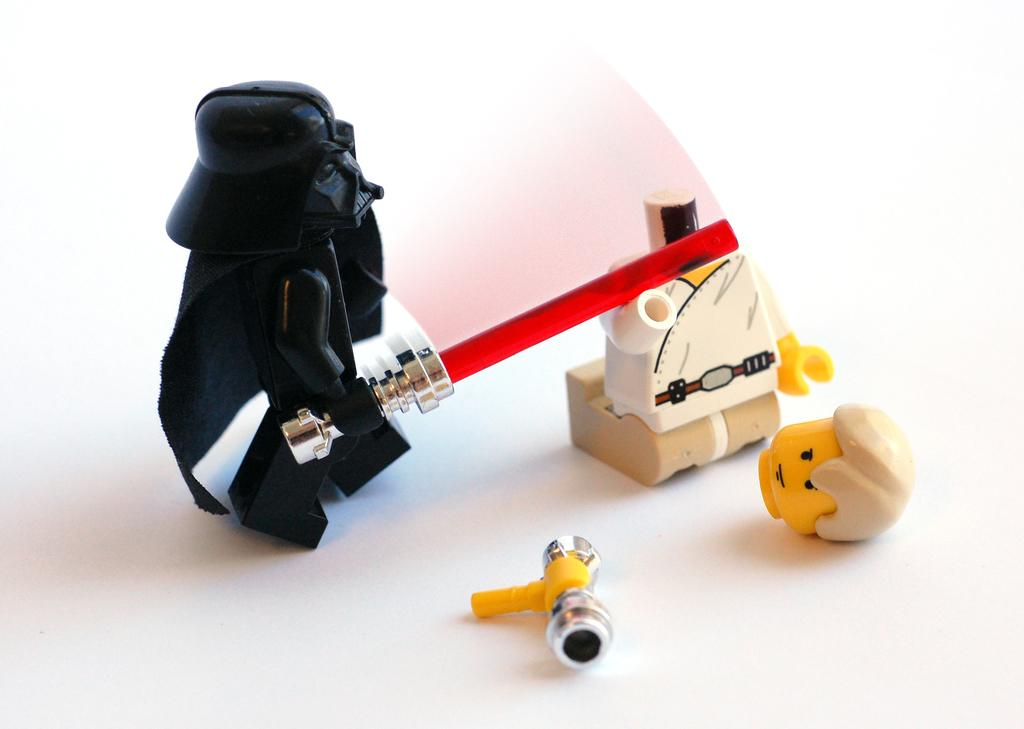What objects are present in the image? There are toys in the image. What is the color of the surface on which the toys are placed? The toys are on a white color surface. What type of trains can be seen in the field in the image? There are no trains or fields present in the image; it only features toys on a white surface. 